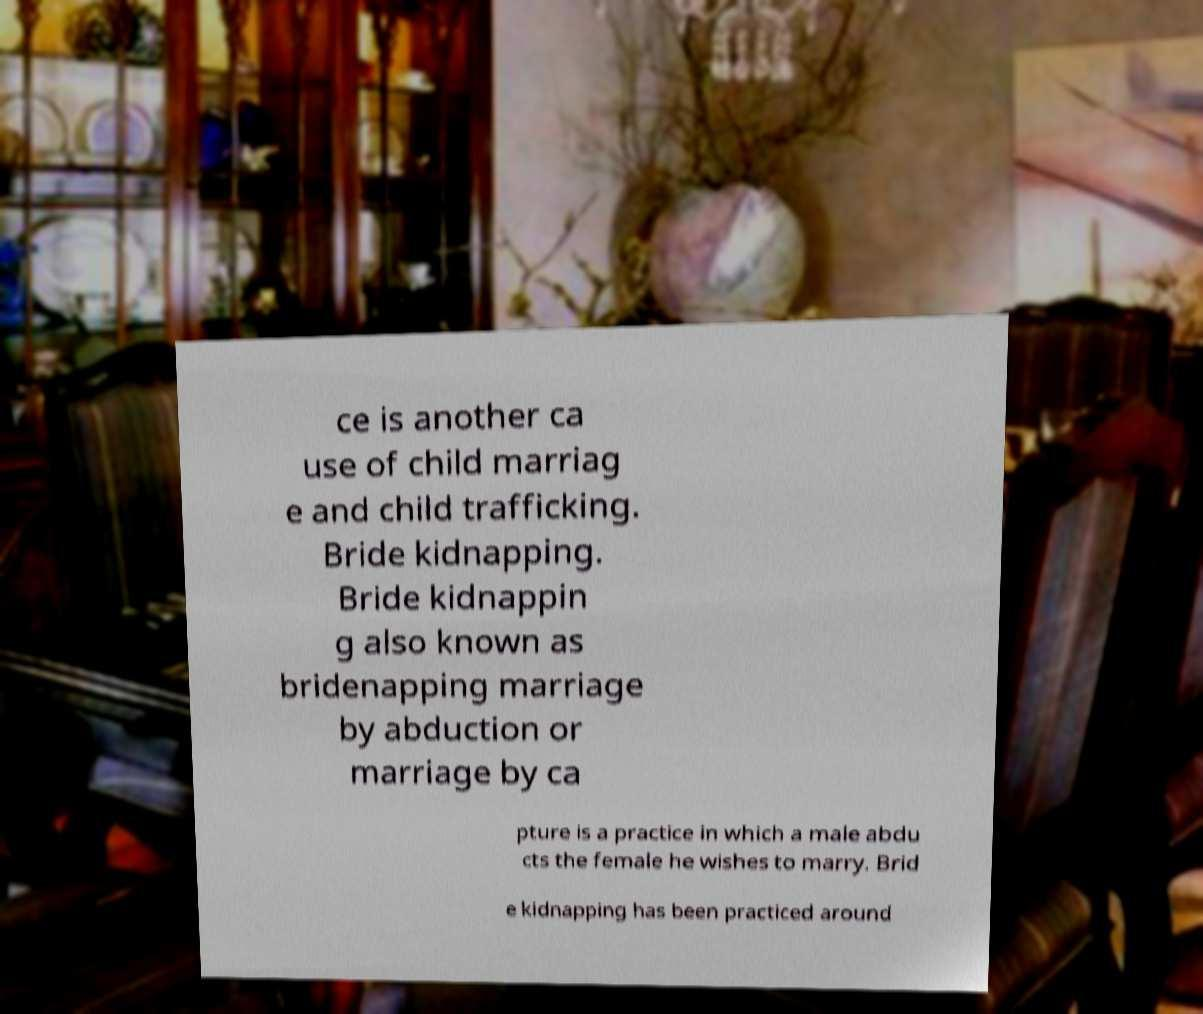I need the written content from this picture converted into text. Can you do that? ce is another ca use of child marriag e and child trafficking. Bride kidnapping. Bride kidnappin g also known as bridenapping marriage by abduction or marriage by ca pture is a practice in which a male abdu cts the female he wishes to marry. Brid e kidnapping has been practiced around 